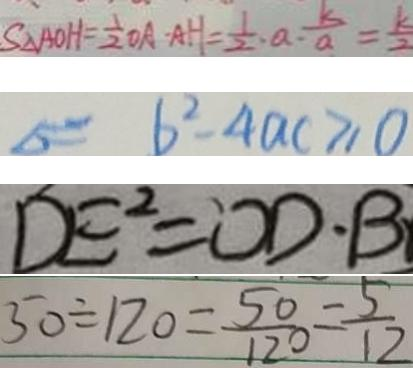Convert formula to latex. <formula><loc_0><loc_0><loc_500><loc_500>S _ { \Delta } A O H = \frac { 1 } { 2 } O A - A H = \frac { 1 } { 2 } \cdot a \cdot \frac { k } { a } = \frac { k } { 2 } 
 \Delta = 6 ^ { 2 } - 4 a c \geq 0 
 D E ^ { 2 } = O D \cdot B 
 5 0 \div 1 2 0 = \frac { 5 0 } { 1 2 0 } = \frac { 5 } { 1 2 }</formula> 